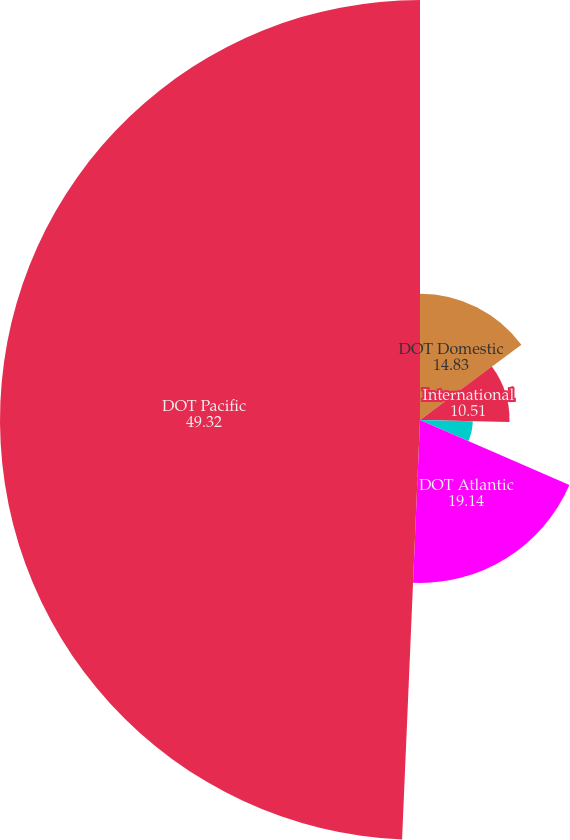Convert chart. <chart><loc_0><loc_0><loc_500><loc_500><pie_chart><fcel>DOT Domestic<fcel>International<fcel>DOT Latin America<fcel>DOT Atlantic<fcel>DOT Pacific<nl><fcel>14.83%<fcel>10.51%<fcel>6.2%<fcel>19.14%<fcel>49.32%<nl></chart> 